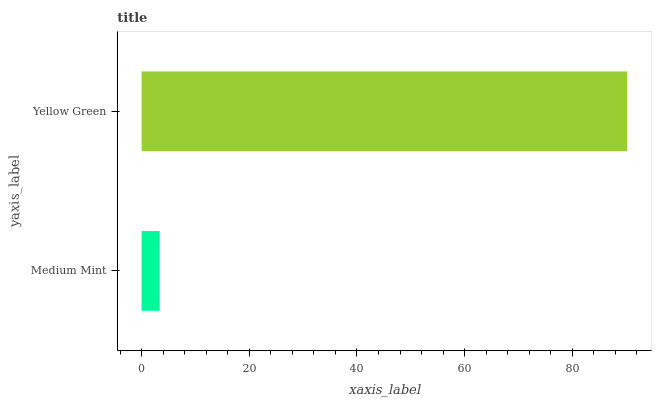Is Medium Mint the minimum?
Answer yes or no. Yes. Is Yellow Green the maximum?
Answer yes or no. Yes. Is Yellow Green the minimum?
Answer yes or no. No. Is Yellow Green greater than Medium Mint?
Answer yes or no. Yes. Is Medium Mint less than Yellow Green?
Answer yes or no. Yes. Is Medium Mint greater than Yellow Green?
Answer yes or no. No. Is Yellow Green less than Medium Mint?
Answer yes or no. No. Is Yellow Green the high median?
Answer yes or no. Yes. Is Medium Mint the low median?
Answer yes or no. Yes. Is Medium Mint the high median?
Answer yes or no. No. Is Yellow Green the low median?
Answer yes or no. No. 